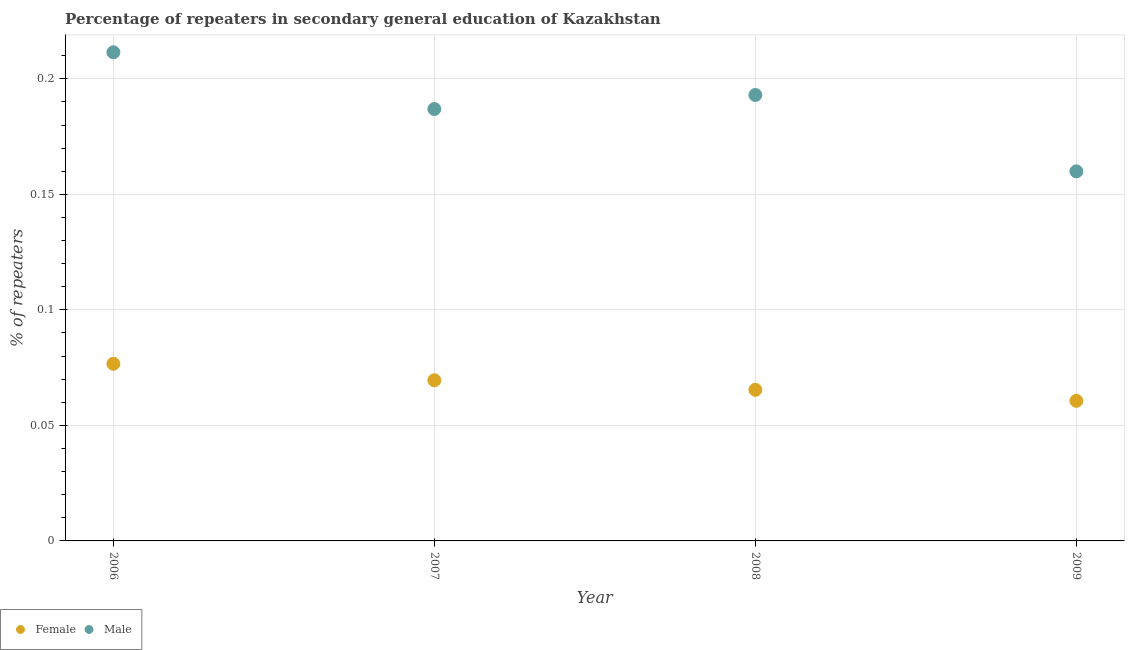What is the percentage of female repeaters in 2009?
Your response must be concise. 0.06. Across all years, what is the maximum percentage of male repeaters?
Offer a terse response. 0.21. Across all years, what is the minimum percentage of male repeaters?
Your answer should be compact. 0.16. In which year was the percentage of female repeaters maximum?
Provide a short and direct response. 2006. What is the total percentage of male repeaters in the graph?
Ensure brevity in your answer.  0.75. What is the difference between the percentage of male repeaters in 2006 and that in 2009?
Keep it short and to the point. 0.05. What is the difference between the percentage of female repeaters in 2009 and the percentage of male repeaters in 2008?
Provide a succinct answer. -0.13. What is the average percentage of male repeaters per year?
Keep it short and to the point. 0.19. In the year 2008, what is the difference between the percentage of male repeaters and percentage of female repeaters?
Your answer should be compact. 0.13. In how many years, is the percentage of male repeaters greater than 0.08 %?
Provide a succinct answer. 4. What is the ratio of the percentage of male repeaters in 2008 to that in 2009?
Your answer should be compact. 1.21. Is the difference between the percentage of male repeaters in 2008 and 2009 greater than the difference between the percentage of female repeaters in 2008 and 2009?
Keep it short and to the point. Yes. What is the difference between the highest and the second highest percentage of male repeaters?
Give a very brief answer. 0.02. What is the difference between the highest and the lowest percentage of female repeaters?
Ensure brevity in your answer.  0.02. In how many years, is the percentage of female repeaters greater than the average percentage of female repeaters taken over all years?
Offer a terse response. 2. Is the percentage of male repeaters strictly greater than the percentage of female repeaters over the years?
Offer a terse response. Yes. How many dotlines are there?
Your response must be concise. 2. What is the difference between two consecutive major ticks on the Y-axis?
Give a very brief answer. 0.05. Are the values on the major ticks of Y-axis written in scientific E-notation?
Make the answer very short. No. Does the graph contain any zero values?
Your response must be concise. No. Where does the legend appear in the graph?
Offer a terse response. Bottom left. How many legend labels are there?
Offer a very short reply. 2. What is the title of the graph?
Offer a very short reply. Percentage of repeaters in secondary general education of Kazakhstan. What is the label or title of the Y-axis?
Make the answer very short. % of repeaters. What is the % of repeaters in Female in 2006?
Your answer should be very brief. 0.08. What is the % of repeaters of Male in 2006?
Give a very brief answer. 0.21. What is the % of repeaters of Female in 2007?
Make the answer very short. 0.07. What is the % of repeaters in Male in 2007?
Provide a succinct answer. 0.19. What is the % of repeaters in Female in 2008?
Ensure brevity in your answer.  0.07. What is the % of repeaters in Male in 2008?
Offer a terse response. 0.19. What is the % of repeaters of Female in 2009?
Make the answer very short. 0.06. What is the % of repeaters of Male in 2009?
Provide a succinct answer. 0.16. Across all years, what is the maximum % of repeaters in Female?
Your answer should be compact. 0.08. Across all years, what is the maximum % of repeaters in Male?
Your answer should be compact. 0.21. Across all years, what is the minimum % of repeaters of Female?
Give a very brief answer. 0.06. Across all years, what is the minimum % of repeaters of Male?
Keep it short and to the point. 0.16. What is the total % of repeaters in Female in the graph?
Give a very brief answer. 0.27. What is the total % of repeaters in Male in the graph?
Ensure brevity in your answer.  0.75. What is the difference between the % of repeaters in Female in 2006 and that in 2007?
Offer a terse response. 0.01. What is the difference between the % of repeaters of Male in 2006 and that in 2007?
Your answer should be compact. 0.02. What is the difference between the % of repeaters of Female in 2006 and that in 2008?
Provide a short and direct response. 0.01. What is the difference between the % of repeaters in Male in 2006 and that in 2008?
Provide a short and direct response. 0.02. What is the difference between the % of repeaters of Female in 2006 and that in 2009?
Offer a terse response. 0.02. What is the difference between the % of repeaters of Male in 2006 and that in 2009?
Provide a succinct answer. 0.05. What is the difference between the % of repeaters in Female in 2007 and that in 2008?
Your response must be concise. 0. What is the difference between the % of repeaters of Male in 2007 and that in 2008?
Make the answer very short. -0.01. What is the difference between the % of repeaters of Female in 2007 and that in 2009?
Keep it short and to the point. 0.01. What is the difference between the % of repeaters of Male in 2007 and that in 2009?
Your answer should be very brief. 0.03. What is the difference between the % of repeaters in Female in 2008 and that in 2009?
Your answer should be very brief. 0. What is the difference between the % of repeaters of Male in 2008 and that in 2009?
Provide a short and direct response. 0.03. What is the difference between the % of repeaters of Female in 2006 and the % of repeaters of Male in 2007?
Keep it short and to the point. -0.11. What is the difference between the % of repeaters in Female in 2006 and the % of repeaters in Male in 2008?
Your response must be concise. -0.12. What is the difference between the % of repeaters in Female in 2006 and the % of repeaters in Male in 2009?
Your answer should be compact. -0.08. What is the difference between the % of repeaters of Female in 2007 and the % of repeaters of Male in 2008?
Give a very brief answer. -0.12. What is the difference between the % of repeaters of Female in 2007 and the % of repeaters of Male in 2009?
Keep it short and to the point. -0.09. What is the difference between the % of repeaters in Female in 2008 and the % of repeaters in Male in 2009?
Offer a very short reply. -0.09. What is the average % of repeaters in Female per year?
Give a very brief answer. 0.07. What is the average % of repeaters of Male per year?
Offer a terse response. 0.19. In the year 2006, what is the difference between the % of repeaters of Female and % of repeaters of Male?
Keep it short and to the point. -0.13. In the year 2007, what is the difference between the % of repeaters in Female and % of repeaters in Male?
Offer a very short reply. -0.12. In the year 2008, what is the difference between the % of repeaters in Female and % of repeaters in Male?
Your response must be concise. -0.13. In the year 2009, what is the difference between the % of repeaters in Female and % of repeaters in Male?
Give a very brief answer. -0.1. What is the ratio of the % of repeaters in Female in 2006 to that in 2007?
Your answer should be very brief. 1.1. What is the ratio of the % of repeaters in Male in 2006 to that in 2007?
Offer a terse response. 1.13. What is the ratio of the % of repeaters of Female in 2006 to that in 2008?
Provide a succinct answer. 1.17. What is the ratio of the % of repeaters in Male in 2006 to that in 2008?
Offer a very short reply. 1.1. What is the ratio of the % of repeaters in Female in 2006 to that in 2009?
Offer a terse response. 1.26. What is the ratio of the % of repeaters of Male in 2006 to that in 2009?
Give a very brief answer. 1.32. What is the ratio of the % of repeaters of Female in 2007 to that in 2008?
Provide a succinct answer. 1.06. What is the ratio of the % of repeaters of Male in 2007 to that in 2008?
Keep it short and to the point. 0.97. What is the ratio of the % of repeaters in Female in 2007 to that in 2009?
Ensure brevity in your answer.  1.15. What is the ratio of the % of repeaters of Male in 2007 to that in 2009?
Your answer should be very brief. 1.17. What is the ratio of the % of repeaters of Female in 2008 to that in 2009?
Provide a succinct answer. 1.08. What is the ratio of the % of repeaters in Male in 2008 to that in 2009?
Keep it short and to the point. 1.21. What is the difference between the highest and the second highest % of repeaters of Female?
Offer a terse response. 0.01. What is the difference between the highest and the second highest % of repeaters in Male?
Offer a very short reply. 0.02. What is the difference between the highest and the lowest % of repeaters in Female?
Provide a short and direct response. 0.02. What is the difference between the highest and the lowest % of repeaters of Male?
Offer a very short reply. 0.05. 